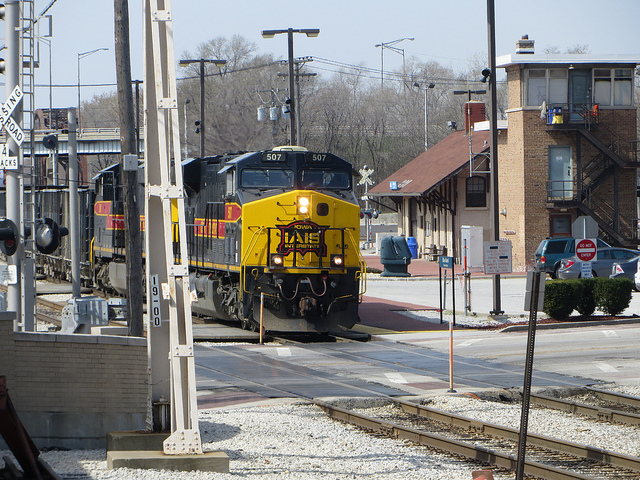Identify the text contained in this image. 507 507 19 00 ACKS 4 ROAD SING 